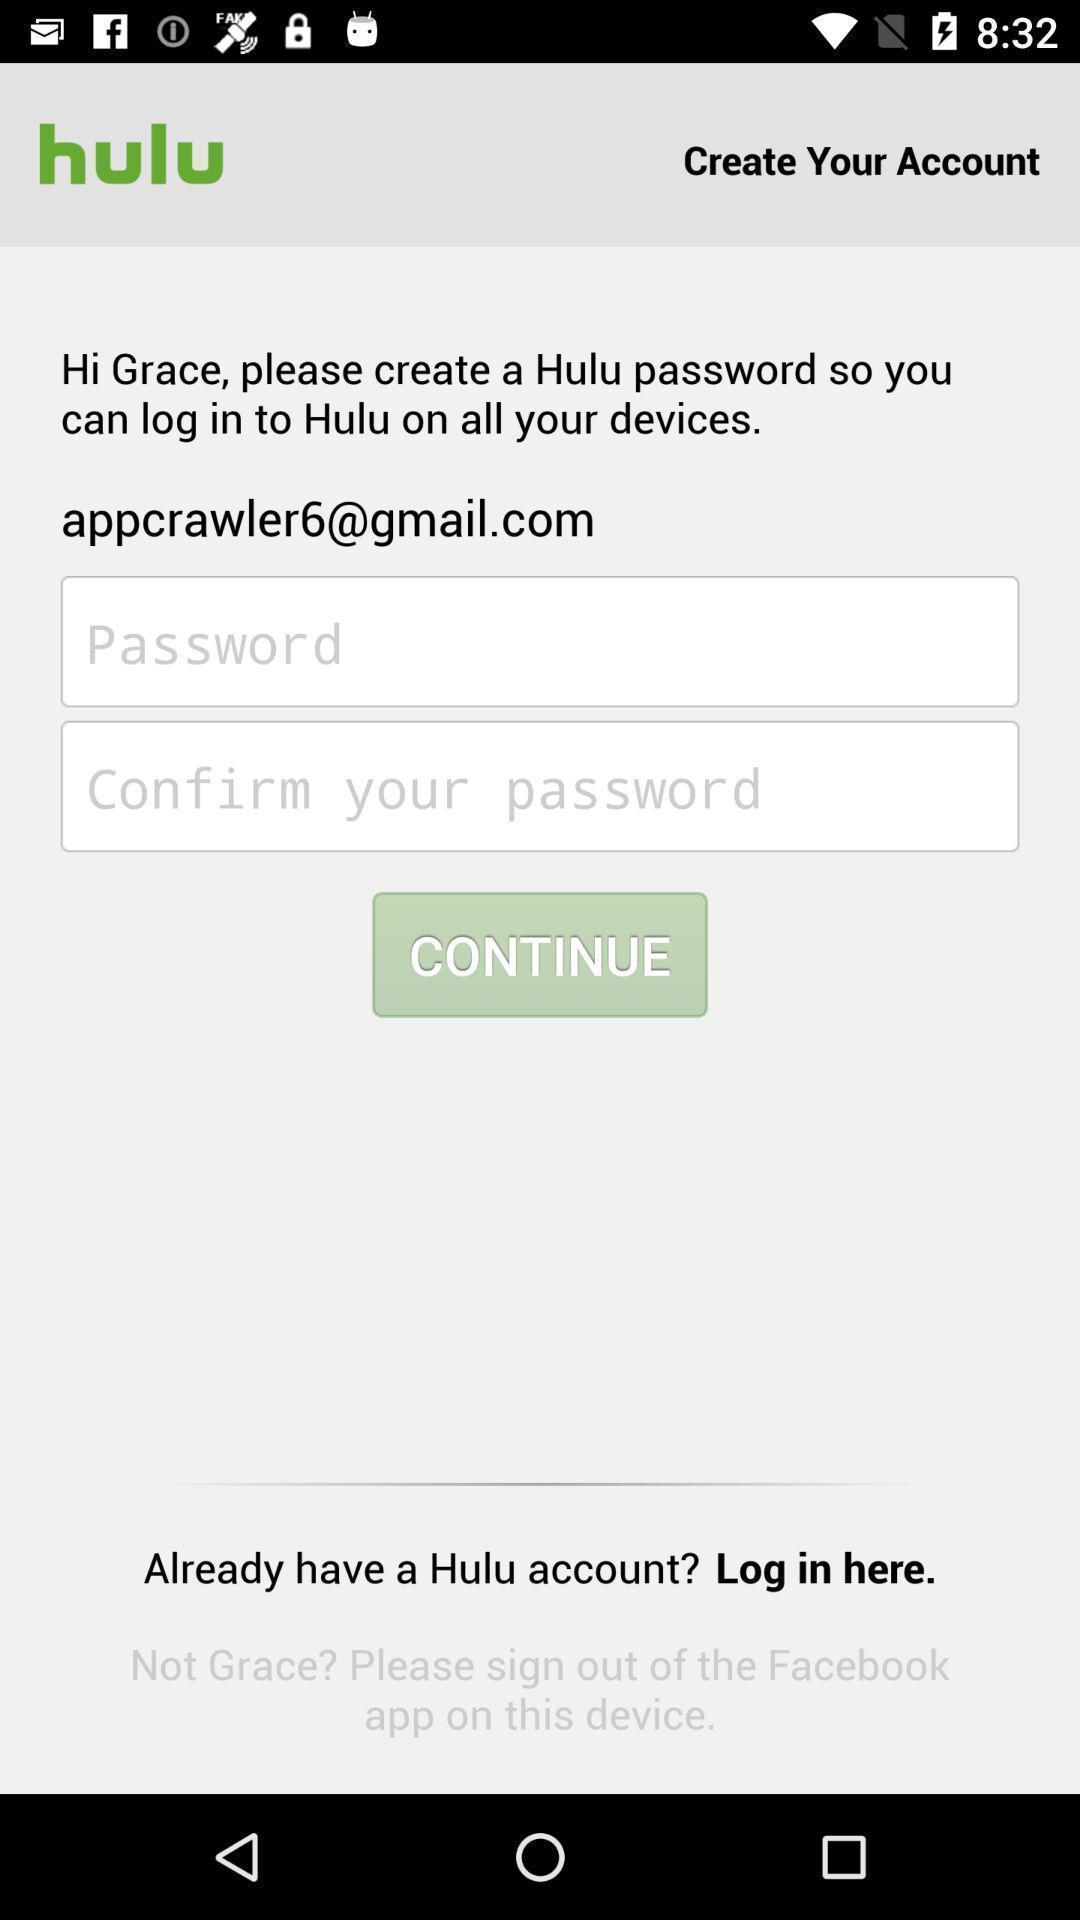Summarize the information in this screenshot. Screen shows create password to continue with an app. 